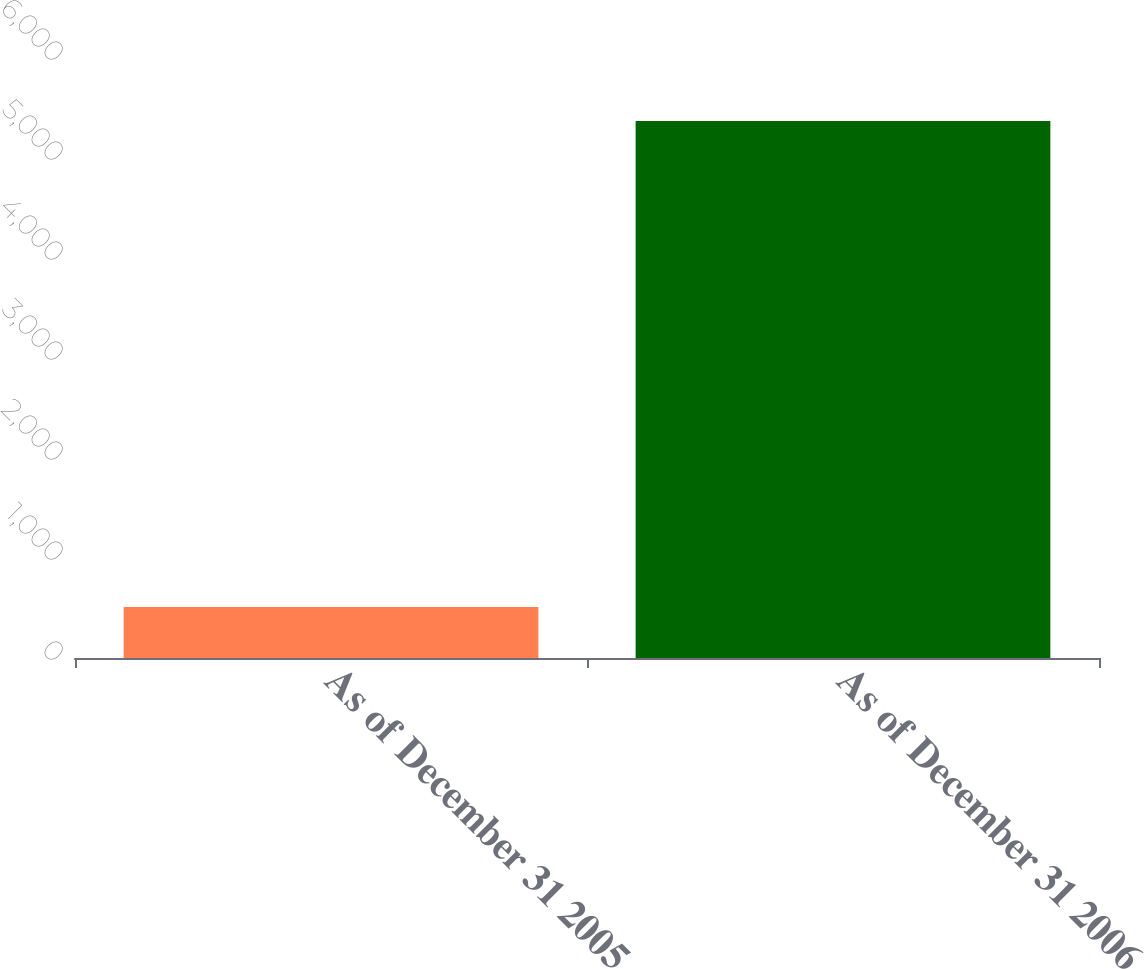<chart> <loc_0><loc_0><loc_500><loc_500><bar_chart><fcel>As of December 31 2005<fcel>As of December 31 2006<nl><fcel>509<fcel>5369<nl></chart> 